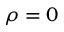<formula> <loc_0><loc_0><loc_500><loc_500>\rho = 0</formula> 